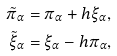Convert formula to latex. <formula><loc_0><loc_0><loc_500><loc_500>\tilde { \pi } _ { \alpha } & = \pi _ { \alpha } + h \xi _ { \alpha } , \\ \tilde { \xi } _ { \alpha } & = \xi _ { \alpha } - h \pi _ { \alpha } ,</formula> 